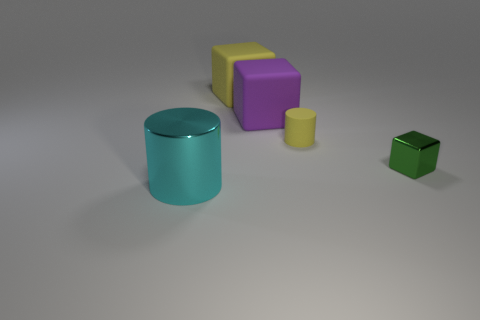What size is the thing that is the same color as the tiny rubber cylinder?
Provide a succinct answer. Large. How many objects are yellow matte objects that are to the left of the purple thing or cylinders that are left of the small yellow rubber thing?
Make the answer very short. 2. There is a thing that is in front of the small matte cylinder and to the right of the large yellow matte thing; what is its size?
Give a very brief answer. Small. Is the shape of the tiny yellow matte object the same as the large thing that is in front of the yellow cylinder?
Your answer should be compact. Yes. What number of things are shiny things that are left of the small green shiny block or yellow shiny objects?
Your answer should be very brief. 1. Are the big purple cube and the cylinder on the left side of the purple matte object made of the same material?
Your response must be concise. No. There is a big rubber thing on the right side of the yellow block behind the green metallic object; what is its shape?
Provide a short and direct response. Cube. Do the small matte cylinder and the matte object to the left of the purple rubber block have the same color?
Provide a succinct answer. Yes. What is the shape of the small yellow matte object?
Provide a succinct answer. Cylinder. How big is the yellow object that is on the right side of the large thing that is behind the large purple rubber cube?
Keep it short and to the point. Small. 